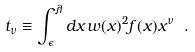<formula> <loc_0><loc_0><loc_500><loc_500>t _ { \nu } \equiv \int _ { \epsilon } ^ { \lambda } d x \, w ( x ) ^ { 2 } f ( x ) x ^ { \nu } \ .</formula> 